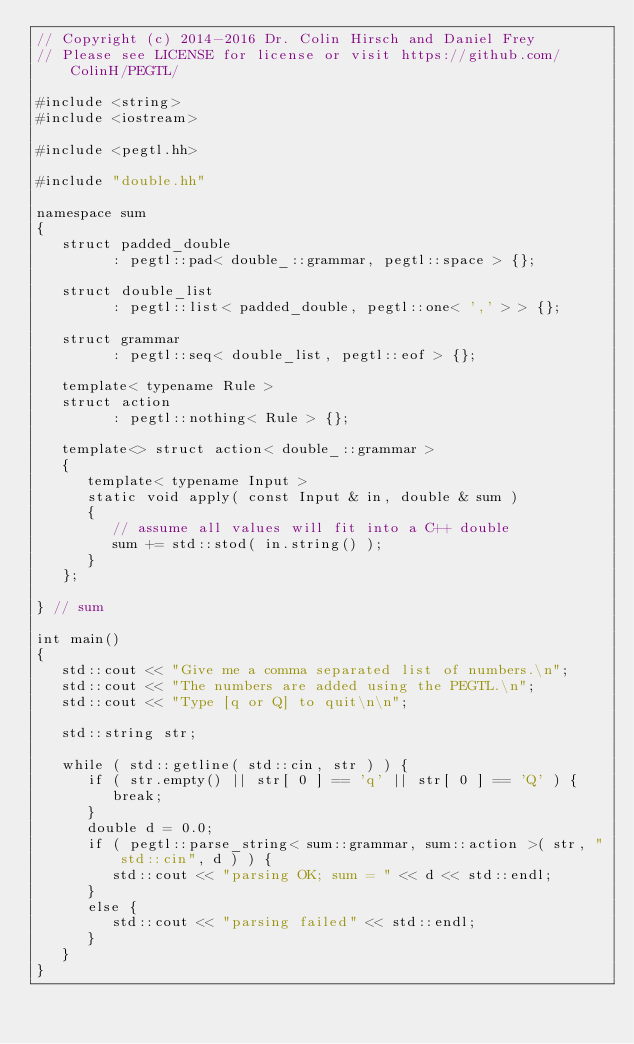Convert code to text. <code><loc_0><loc_0><loc_500><loc_500><_C++_>// Copyright (c) 2014-2016 Dr. Colin Hirsch and Daniel Frey
// Please see LICENSE for license or visit https://github.com/ColinH/PEGTL/

#include <string>
#include <iostream>

#include <pegtl.hh>

#include "double.hh"

namespace sum
{
   struct padded_double
         : pegtl::pad< double_::grammar, pegtl::space > {};

   struct double_list
         : pegtl::list< padded_double, pegtl::one< ',' > > {};

   struct grammar
         : pegtl::seq< double_list, pegtl::eof > {};

   template< typename Rule >
   struct action
         : pegtl::nothing< Rule > {};

   template<> struct action< double_::grammar >
   {
      template< typename Input >
      static void apply( const Input & in, double & sum )
      {
         // assume all values will fit into a C++ double
         sum += std::stod( in.string() );
      }
   };

} // sum

int main()
{
   std::cout << "Give me a comma separated list of numbers.\n";
   std::cout << "The numbers are added using the PEGTL.\n";
   std::cout << "Type [q or Q] to quit\n\n";

   std::string str;

   while ( std::getline( std::cin, str ) ) {
      if ( str.empty() || str[ 0 ] == 'q' || str[ 0 ] == 'Q' ) {
         break;
      }
      double d = 0.0;
      if ( pegtl::parse_string< sum::grammar, sum::action >( str, "std::cin", d ) ) {
         std::cout << "parsing OK; sum = " << d << std::endl;
      }
      else {
         std::cout << "parsing failed" << std::endl;
      }
   }
}
</code> 